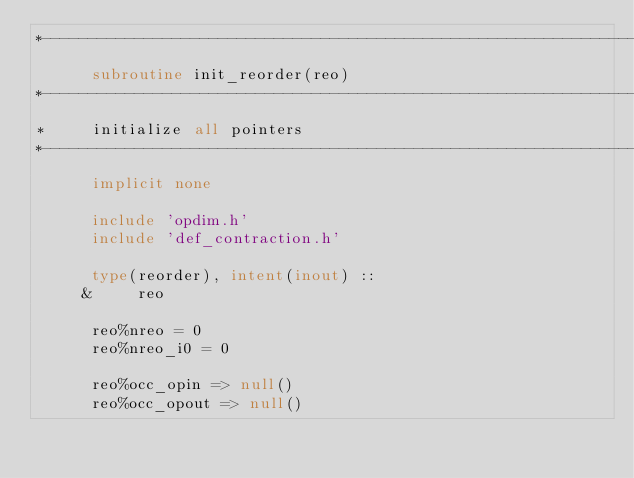<code> <loc_0><loc_0><loc_500><loc_500><_FORTRAN_>*----------------------------------------------------------------------*
      subroutine init_reorder(reo)
*----------------------------------------------------------------------*
*     initialize all pointers 
*----------------------------------------------------------------------*
      implicit none

      include 'opdim.h'
      include 'def_contraction.h'

      type(reorder), intent(inout) ::
     &     reo

      reo%nreo = 0
      reo%nreo_i0 = 0
      
      reo%occ_opin => null()
      reo%occ_opout => null()</code> 